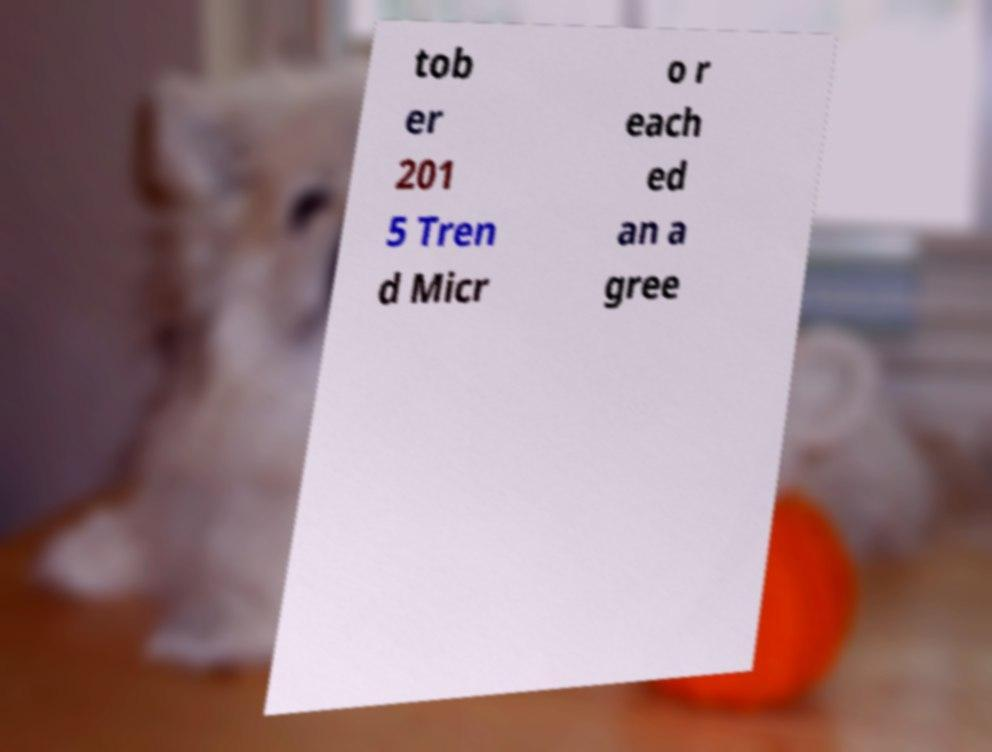Could you assist in decoding the text presented in this image and type it out clearly? tob er 201 5 Tren d Micr o r each ed an a gree 